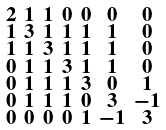<formula> <loc_0><loc_0><loc_500><loc_500>\begin{smallmatrix} 2 & 1 & 1 & 0 & 0 & 0 & 0 \\ 1 & 3 & 1 & 1 & 1 & 1 & 0 \\ 1 & 1 & 3 & 1 & 1 & 1 & 0 \\ 0 & 1 & 1 & 3 & 1 & 1 & 0 \\ 0 & 1 & 1 & 1 & 3 & 0 & 1 \\ 0 & 1 & 1 & 1 & 0 & 3 & - 1 \\ 0 & 0 & 0 & 0 & 1 & - 1 & 3 \end{smallmatrix}</formula> 